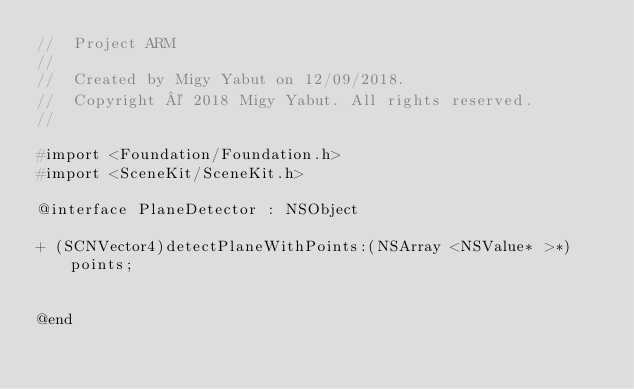Convert code to text. <code><loc_0><loc_0><loc_500><loc_500><_C_>//  Project ARM
//
//  Created by Migy Yabut on 12/09/2018.
//  Copyright © 2018 Migy Yabut. All rights reserved.
//

#import <Foundation/Foundation.h>
#import <SceneKit/SceneKit.h>

@interface PlaneDetector : NSObject

+ (SCNVector4)detectPlaneWithPoints:(NSArray <NSValue* >*)points;


@end
</code> 